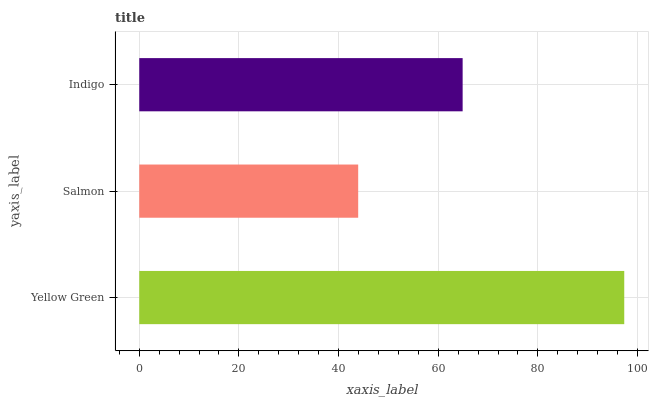Is Salmon the minimum?
Answer yes or no. Yes. Is Yellow Green the maximum?
Answer yes or no. Yes. Is Indigo the minimum?
Answer yes or no. No. Is Indigo the maximum?
Answer yes or no. No. Is Indigo greater than Salmon?
Answer yes or no. Yes. Is Salmon less than Indigo?
Answer yes or no. Yes. Is Salmon greater than Indigo?
Answer yes or no. No. Is Indigo less than Salmon?
Answer yes or no. No. Is Indigo the high median?
Answer yes or no. Yes. Is Indigo the low median?
Answer yes or no. Yes. Is Yellow Green the high median?
Answer yes or no. No. Is Salmon the low median?
Answer yes or no. No. 